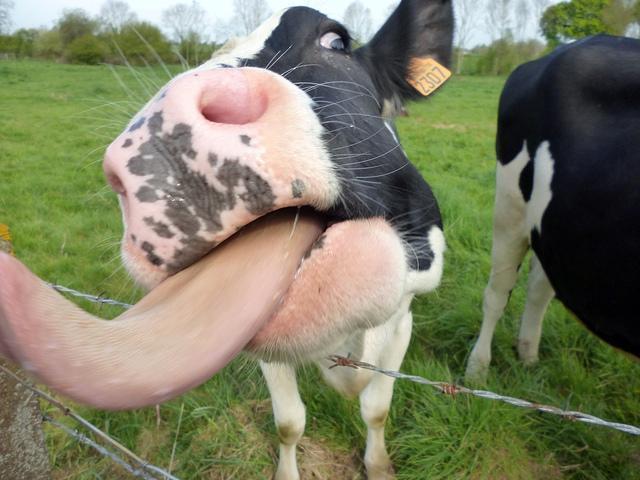How many cows can be seen?
Give a very brief answer. 2. How many elephants are there?
Give a very brief answer. 0. 